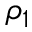<formula> <loc_0><loc_0><loc_500><loc_500>\rho _ { 1 }</formula> 